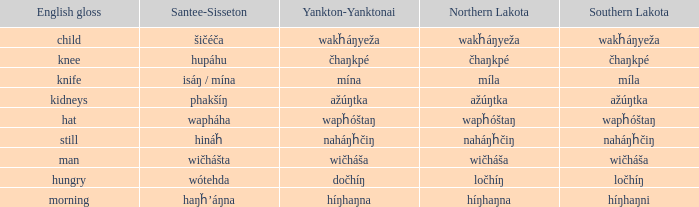Name the number of english gloss for wakȟáŋyeža 1.0. 